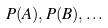Convert formula to latex. <formula><loc_0><loc_0><loc_500><loc_500>P ( A ) , P ( B ) , \dots</formula> 